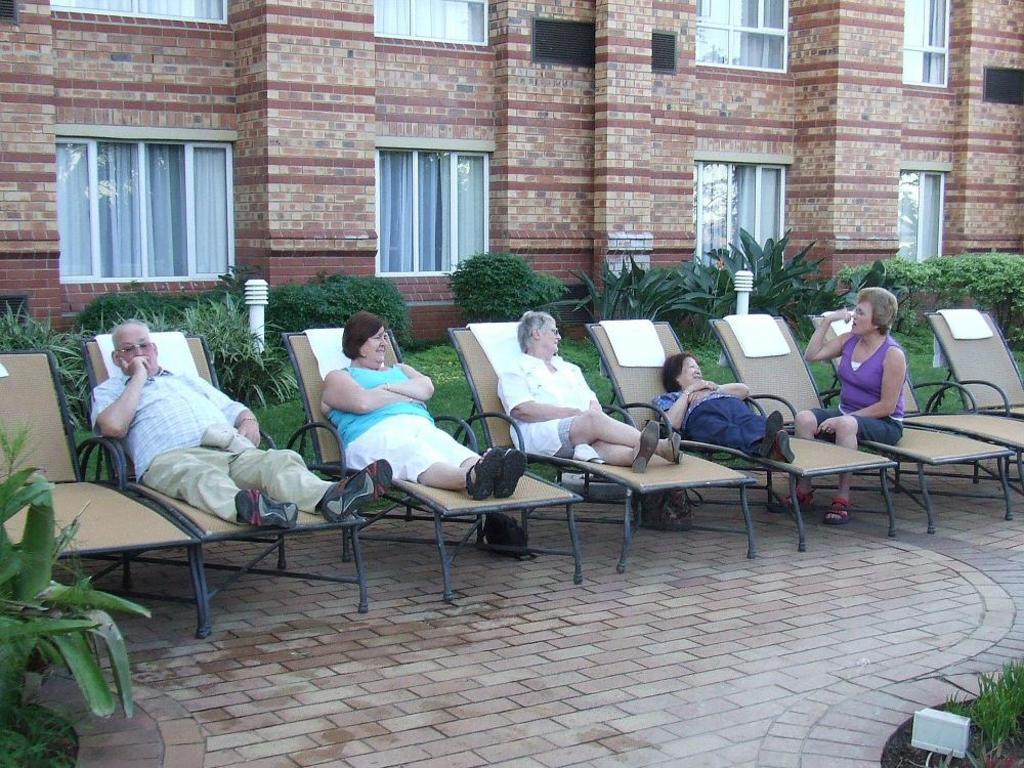What type of structure is visible in the image? There is a building in the image. What feature can be seen on the building? The building has windows. What else is present in the image besides the building? There are plants and people sitting on chairs in the image. How many pizzas are being served to the people sitting on chairs in the image? There is no mention of pizzas in the image; the focus is on the building, windows, plants, and people sitting on chairs. 